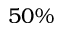Convert formula to latex. <formula><loc_0><loc_0><loc_500><loc_500>5 0 \%</formula> 